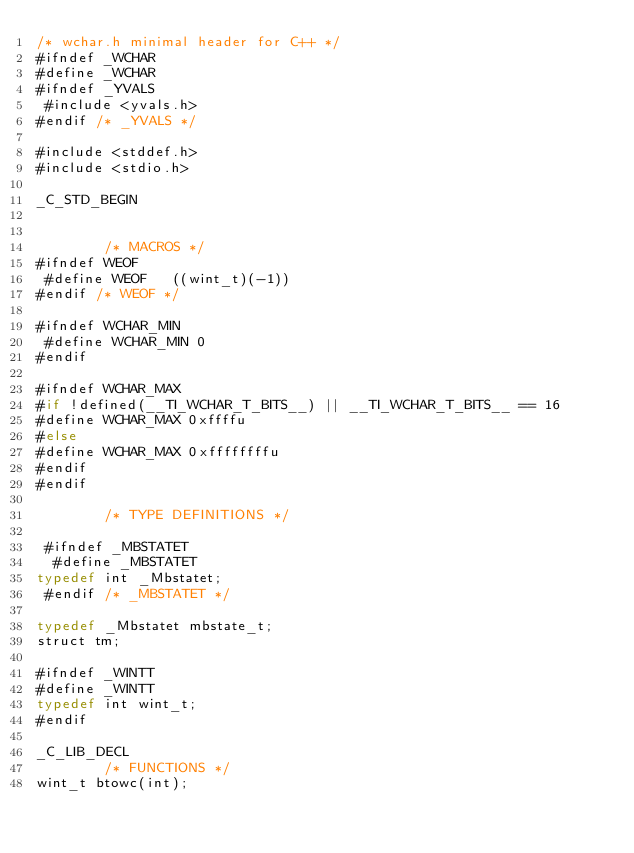<code> <loc_0><loc_0><loc_500><loc_500><_Haxe_>/* wchar.h minimal header for C++ */
#ifndef _WCHAR
#define _WCHAR
#ifndef _YVALS
 #include <yvals.h>
#endif /* _YVALS */

#include <stddef.h>
#include <stdio.h>

_C_STD_BEGIN


		/* MACROS */
#ifndef WEOF
 #define WEOF	((wint_t)(-1))
#endif /* WEOF */

#ifndef WCHAR_MIN
 #define WCHAR_MIN 0
#endif

#ifndef WCHAR_MAX
#if !defined(__TI_WCHAR_T_BITS__) || __TI_WCHAR_T_BITS__ == 16
#define WCHAR_MAX 0xffffu
#else 
#define WCHAR_MAX 0xffffffffu
#endif
#endif

		/* TYPE DEFINITIONS */

 #ifndef _MBSTATET
  #define _MBSTATET
typedef int _Mbstatet;
 #endif /* _MBSTATET */

typedef _Mbstatet mbstate_t;
struct tm;

#ifndef _WINTT
#define _WINTT
typedef int wint_t;
#endif

_C_LIB_DECL
		/* FUNCTIONS */
wint_t btowc(int);</code> 